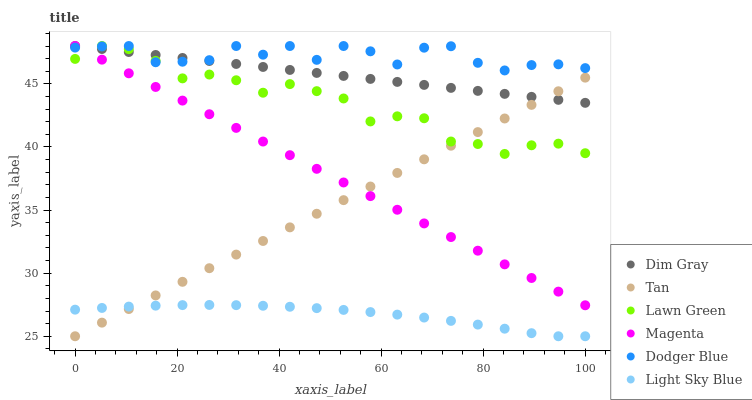Does Light Sky Blue have the minimum area under the curve?
Answer yes or no. Yes. Does Dodger Blue have the maximum area under the curve?
Answer yes or no. Yes. Does Dim Gray have the minimum area under the curve?
Answer yes or no. No. Does Dim Gray have the maximum area under the curve?
Answer yes or no. No. Is Tan the smoothest?
Answer yes or no. Yes. Is Dodger Blue the roughest?
Answer yes or no. Yes. Is Dim Gray the smoothest?
Answer yes or no. No. Is Dim Gray the roughest?
Answer yes or no. No. Does Light Sky Blue have the lowest value?
Answer yes or no. Yes. Does Dim Gray have the lowest value?
Answer yes or no. No. Does Magenta have the highest value?
Answer yes or no. Yes. Does Light Sky Blue have the highest value?
Answer yes or no. No. Is Tan less than Dodger Blue?
Answer yes or no. Yes. Is Lawn Green greater than Light Sky Blue?
Answer yes or no. Yes. Does Dodger Blue intersect Lawn Green?
Answer yes or no. Yes. Is Dodger Blue less than Lawn Green?
Answer yes or no. No. Is Dodger Blue greater than Lawn Green?
Answer yes or no. No. Does Tan intersect Dodger Blue?
Answer yes or no. No. 